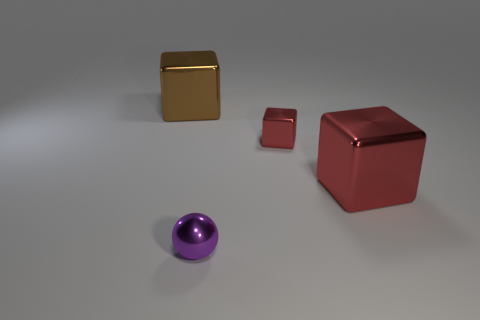How many objects are big cyan balls or tiny spheres?
Give a very brief answer. 1. Is there a large brown object that has the same shape as the small red shiny thing?
Keep it short and to the point. Yes. Is the number of red objects less than the number of tiny purple metallic spheres?
Ensure brevity in your answer.  No. Is the shape of the brown metal object the same as the tiny purple metal thing?
Make the answer very short. No. How many objects are either brown metallic cubes or large metal cubes on the right side of the small shiny sphere?
Keep it short and to the point. 2. What number of small gray shiny cubes are there?
Your answer should be very brief. 0. Is there a red object of the same size as the brown shiny block?
Make the answer very short. Yes. Are there fewer small shiny cubes that are on the right side of the big red object than big cyan matte spheres?
Keep it short and to the point. No. Do the brown metallic cube and the metallic ball have the same size?
Keep it short and to the point. No. What is the size of the purple ball that is made of the same material as the big brown block?
Your answer should be compact. Small. 